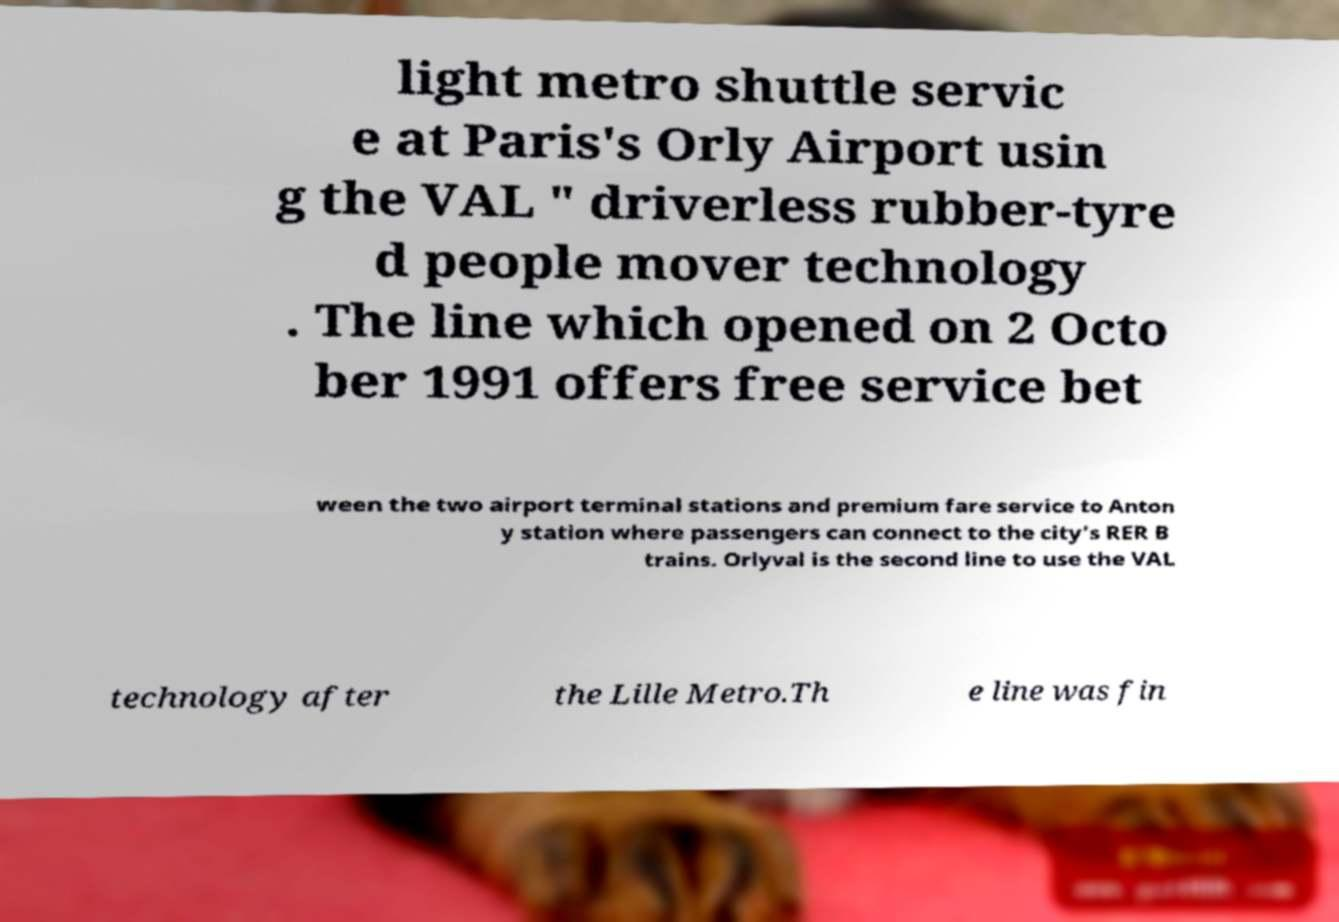Can you read and provide the text displayed in the image?This photo seems to have some interesting text. Can you extract and type it out for me? light metro shuttle servic e at Paris's Orly Airport usin g the VAL " driverless rubber-tyre d people mover technology . The line which opened on 2 Octo ber 1991 offers free service bet ween the two airport terminal stations and premium fare service to Anton y station where passengers can connect to the city's RER B trains. Orlyval is the second line to use the VAL technology after the Lille Metro.Th e line was fin 